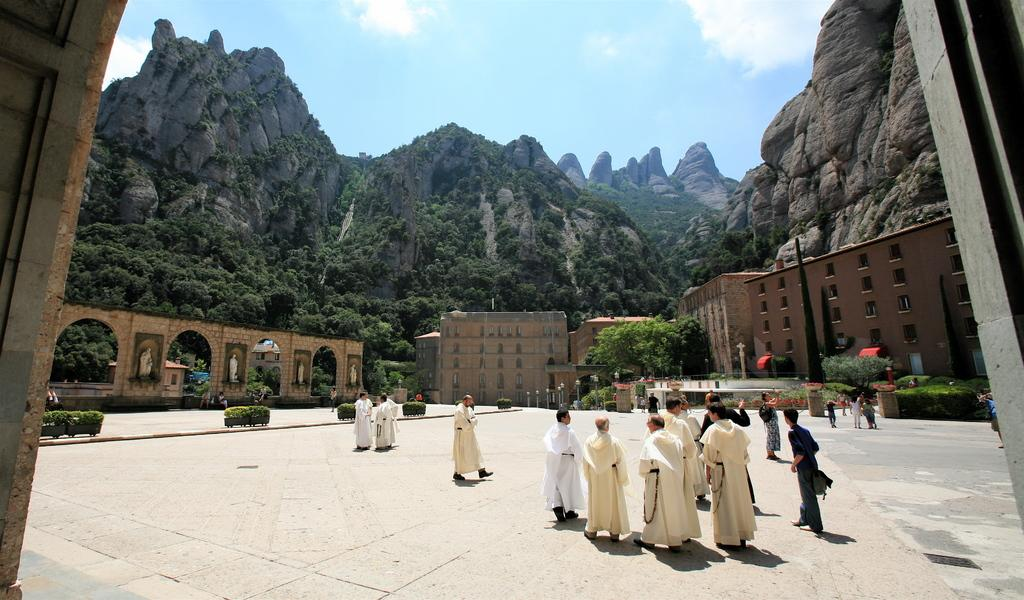What is happening in the foreground of the image? There are persons on the ground in the foreground of the image. What can be seen in the background of the image? There are trees, buildings, a sculpture, plants, poles, mountains, and the sky visible in the background of the image. Can you describe the sky in the image? The sky is visible in the background of the image, and there is a cloud in the sky. What type of vegetable is being used as a mask by the persons in the foreground of the image? There is no vegetable being used as a mask in the image; the persons are not wearing any masks. Where is the bed located in the image? There is no bed present in the image. 